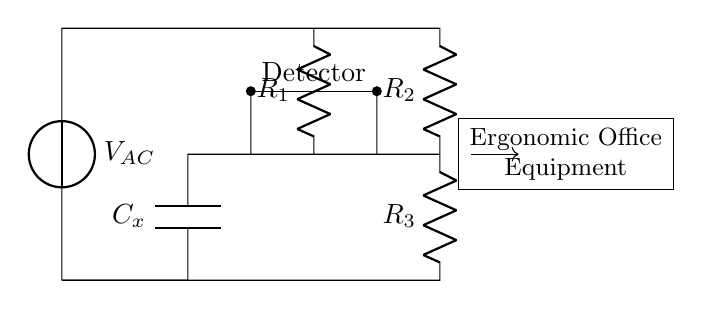What is the voltage source in the circuit? The voltage source in the circuit is represented as V_AC, which provides alternating current (AC) to the circuit.
Answer: V_AC What are the resistors present in the circuit? The resistors present in the circuit are R_1, R_2, and R_3. These components indicate the resistive elements in the bridge configuration.
Answer: R_1, R_2, R_3 How many capacitors are in the circuit? There is one capacitor in the circuit, which is labeled as C_x and is used for testing capacitance.
Answer: 1 What is the role of the detector in the circuit? The detector is used to measure the resulting voltage created by the bridge circuit, which is essential for analyzing the capacitance within the ergonomic office equipment.
Answer: Measure voltage What is the component labeled C_x in the circuit? The component labeled C_x in the circuit is a capacitor, which is used to test the capacitance of the ergonomic office equipment connected within the arrangement.
Answer: Capacitor How are the resistors in the circuit connected? The resistors R_1, R_2, and R_3 are connected in such a way that R_1 and R_3 are in series, while R_2 is connected in parallel with the combination of R_1 and C_x.
Answer: R_1 and R_3 in series; R_2 in parallel 